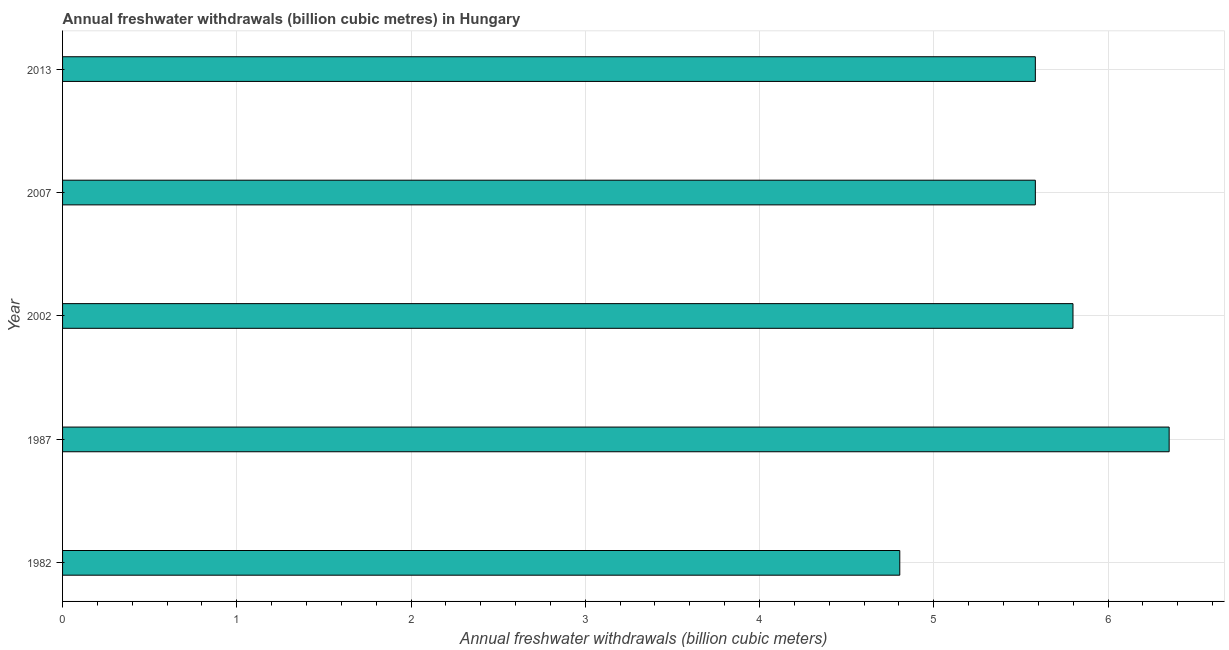Does the graph contain any zero values?
Ensure brevity in your answer.  No. Does the graph contain grids?
Offer a very short reply. Yes. What is the title of the graph?
Offer a terse response. Annual freshwater withdrawals (billion cubic metres) in Hungary. What is the label or title of the X-axis?
Offer a very short reply. Annual freshwater withdrawals (billion cubic meters). What is the label or title of the Y-axis?
Your response must be concise. Year. What is the annual freshwater withdrawals in 2013?
Your response must be concise. 5.58. Across all years, what is the maximum annual freshwater withdrawals?
Your response must be concise. 6.35. Across all years, what is the minimum annual freshwater withdrawals?
Your answer should be compact. 4.8. In which year was the annual freshwater withdrawals maximum?
Provide a short and direct response. 1987. What is the sum of the annual freshwater withdrawals?
Your answer should be compact. 28.12. What is the difference between the annual freshwater withdrawals in 1982 and 1987?
Your answer should be very brief. -1.55. What is the average annual freshwater withdrawals per year?
Keep it short and to the point. 5.62. What is the median annual freshwater withdrawals?
Your answer should be compact. 5.58. In how many years, is the annual freshwater withdrawals greater than 4.2 billion cubic meters?
Your response must be concise. 5. What is the ratio of the annual freshwater withdrawals in 2002 to that in 2013?
Provide a succinct answer. 1.04. Is the annual freshwater withdrawals in 2002 less than that in 2007?
Offer a very short reply. No. What is the difference between the highest and the second highest annual freshwater withdrawals?
Offer a terse response. 0.55. Is the sum of the annual freshwater withdrawals in 2007 and 2013 greater than the maximum annual freshwater withdrawals across all years?
Offer a terse response. Yes. What is the difference between the highest and the lowest annual freshwater withdrawals?
Your answer should be very brief. 1.55. How many bars are there?
Make the answer very short. 5. How many years are there in the graph?
Provide a succinct answer. 5. What is the difference between two consecutive major ticks on the X-axis?
Keep it short and to the point. 1. What is the Annual freshwater withdrawals (billion cubic meters) of 1982?
Give a very brief answer. 4.8. What is the Annual freshwater withdrawals (billion cubic meters) of 1987?
Your response must be concise. 6.35. What is the Annual freshwater withdrawals (billion cubic meters) in 2002?
Provide a short and direct response. 5.8. What is the Annual freshwater withdrawals (billion cubic meters) in 2007?
Offer a very short reply. 5.58. What is the Annual freshwater withdrawals (billion cubic meters) of 2013?
Your answer should be very brief. 5.58. What is the difference between the Annual freshwater withdrawals (billion cubic meters) in 1982 and 1987?
Offer a terse response. -1.55. What is the difference between the Annual freshwater withdrawals (billion cubic meters) in 1982 and 2002?
Ensure brevity in your answer.  -0.99. What is the difference between the Annual freshwater withdrawals (billion cubic meters) in 1982 and 2007?
Offer a very short reply. -0.78. What is the difference between the Annual freshwater withdrawals (billion cubic meters) in 1982 and 2013?
Your response must be concise. -0.78. What is the difference between the Annual freshwater withdrawals (billion cubic meters) in 1987 and 2002?
Offer a terse response. 0.55. What is the difference between the Annual freshwater withdrawals (billion cubic meters) in 1987 and 2007?
Ensure brevity in your answer.  0.77. What is the difference between the Annual freshwater withdrawals (billion cubic meters) in 1987 and 2013?
Offer a very short reply. 0.77. What is the difference between the Annual freshwater withdrawals (billion cubic meters) in 2002 and 2007?
Provide a succinct answer. 0.22. What is the difference between the Annual freshwater withdrawals (billion cubic meters) in 2002 and 2013?
Keep it short and to the point. 0.22. What is the difference between the Annual freshwater withdrawals (billion cubic meters) in 2007 and 2013?
Offer a very short reply. 0. What is the ratio of the Annual freshwater withdrawals (billion cubic meters) in 1982 to that in 1987?
Provide a succinct answer. 0.76. What is the ratio of the Annual freshwater withdrawals (billion cubic meters) in 1982 to that in 2002?
Offer a very short reply. 0.83. What is the ratio of the Annual freshwater withdrawals (billion cubic meters) in 1982 to that in 2007?
Keep it short and to the point. 0.86. What is the ratio of the Annual freshwater withdrawals (billion cubic meters) in 1982 to that in 2013?
Give a very brief answer. 0.86. What is the ratio of the Annual freshwater withdrawals (billion cubic meters) in 1987 to that in 2002?
Keep it short and to the point. 1.09. What is the ratio of the Annual freshwater withdrawals (billion cubic meters) in 1987 to that in 2007?
Your answer should be very brief. 1.14. What is the ratio of the Annual freshwater withdrawals (billion cubic meters) in 1987 to that in 2013?
Offer a terse response. 1.14. What is the ratio of the Annual freshwater withdrawals (billion cubic meters) in 2002 to that in 2007?
Make the answer very short. 1.04. What is the ratio of the Annual freshwater withdrawals (billion cubic meters) in 2002 to that in 2013?
Ensure brevity in your answer.  1.04. What is the ratio of the Annual freshwater withdrawals (billion cubic meters) in 2007 to that in 2013?
Offer a terse response. 1. 